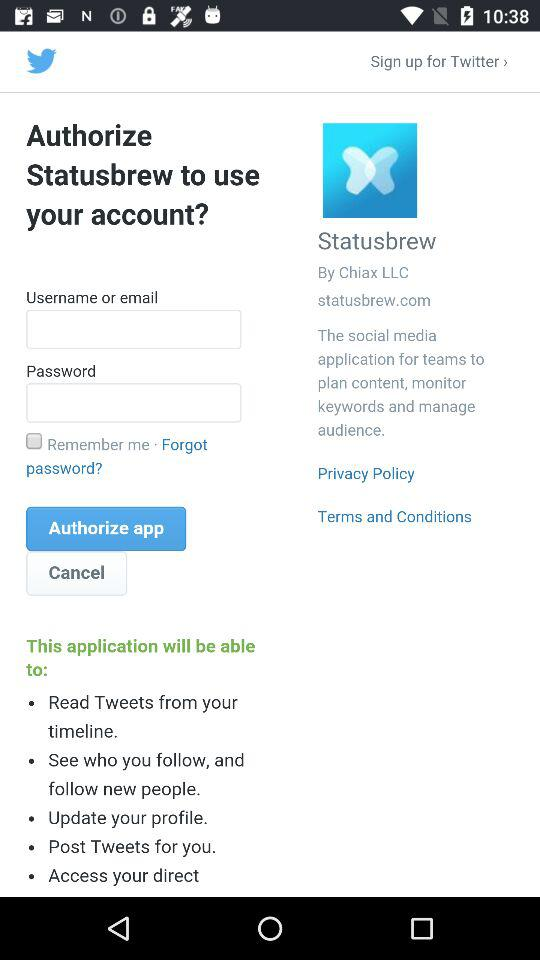What is the name of the application? The names of the applications are "Twitter" and "Statusbrew". 